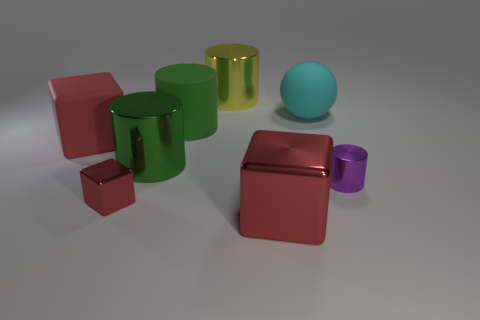What time of day would this lighting suggest? The lighting in the image does not strongly suggest any particular time of day, as it appears to be a controlled environment with artificial lighting. The shadows are soft and diffuse, indicative of a light source that is not as harsh or direct as natural sunlight. 